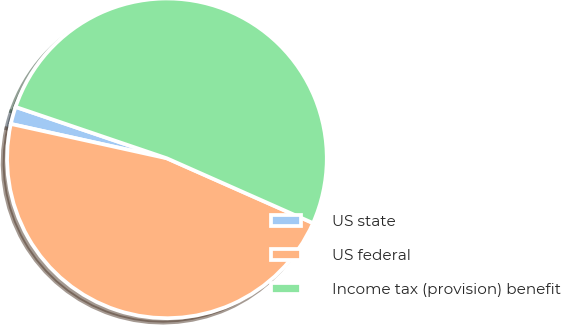<chart> <loc_0><loc_0><loc_500><loc_500><pie_chart><fcel>US state<fcel>US federal<fcel>Income tax (provision) benefit<nl><fcel>1.76%<fcel>46.81%<fcel>51.43%<nl></chart> 